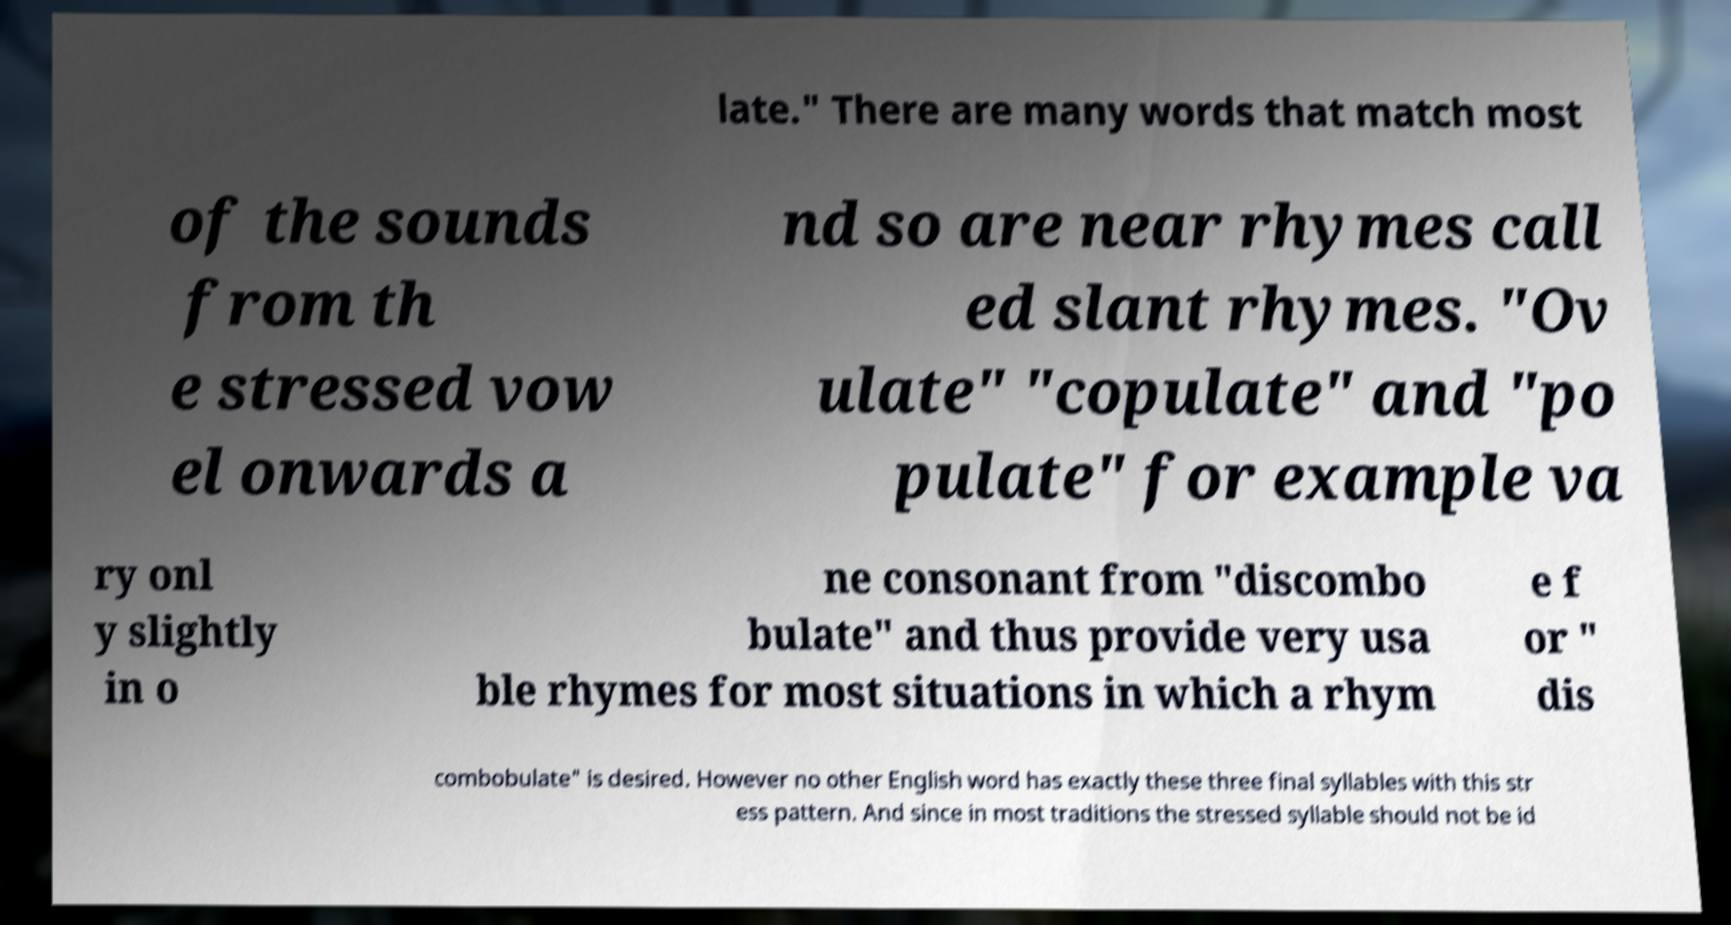Please identify and transcribe the text found in this image. late." There are many words that match most of the sounds from th e stressed vow el onwards a nd so are near rhymes call ed slant rhymes. "Ov ulate" "copulate" and "po pulate" for example va ry onl y slightly in o ne consonant from "discombo bulate" and thus provide very usa ble rhymes for most situations in which a rhym e f or " dis combobulate" is desired. However no other English word has exactly these three final syllables with this str ess pattern. And since in most traditions the stressed syllable should not be id 